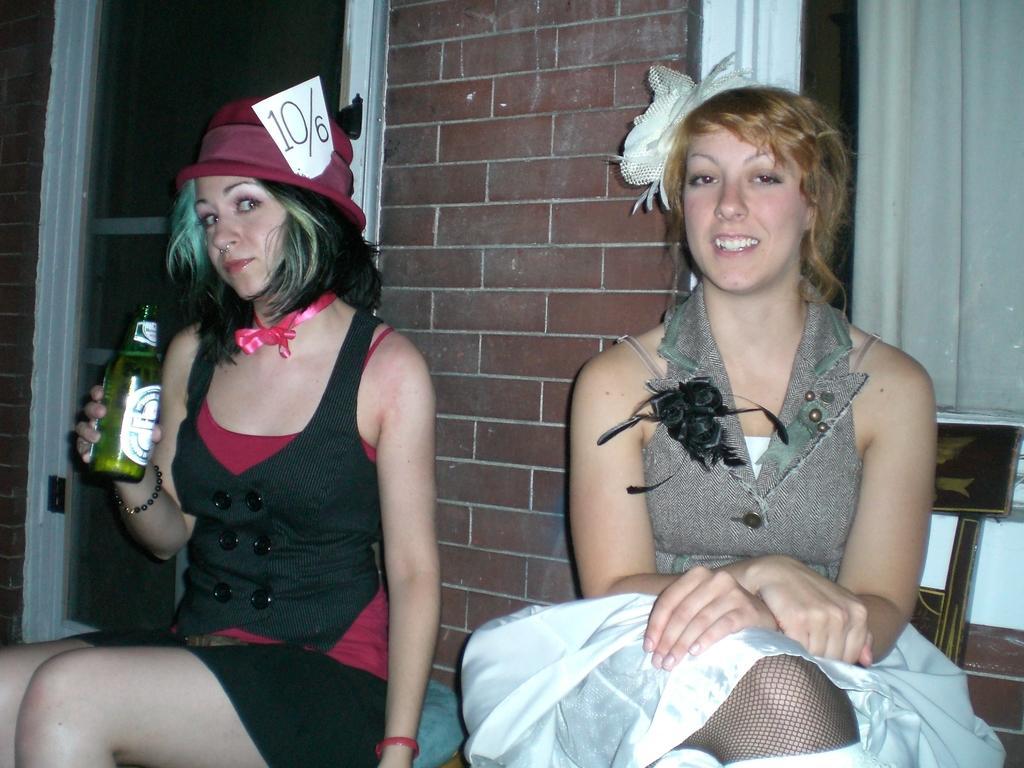In one or two sentences, can you explain what this image depicts? There are two women sitting on the chair as we can see at the bottom of this image. The woman sitting on the left side is holding a bottle. There is a wall in the background. We can see a window and a curtain is on the right side of this image and a glass door is on the left side of this image. 